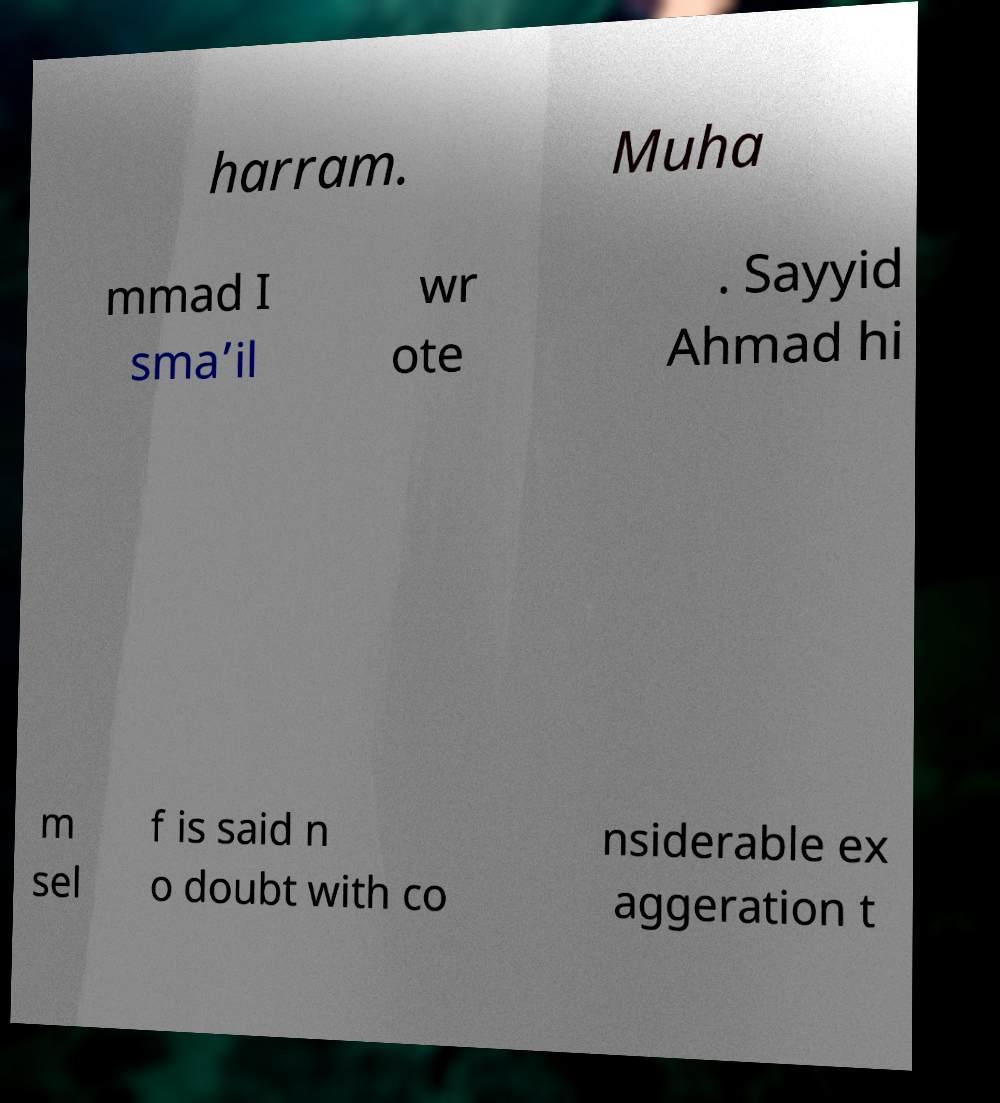Please read and relay the text visible in this image. What does it say? harram. Muha mmad I sma’il wr ote . Sayyid Ahmad hi m sel f is said n o doubt with co nsiderable ex aggeration t 